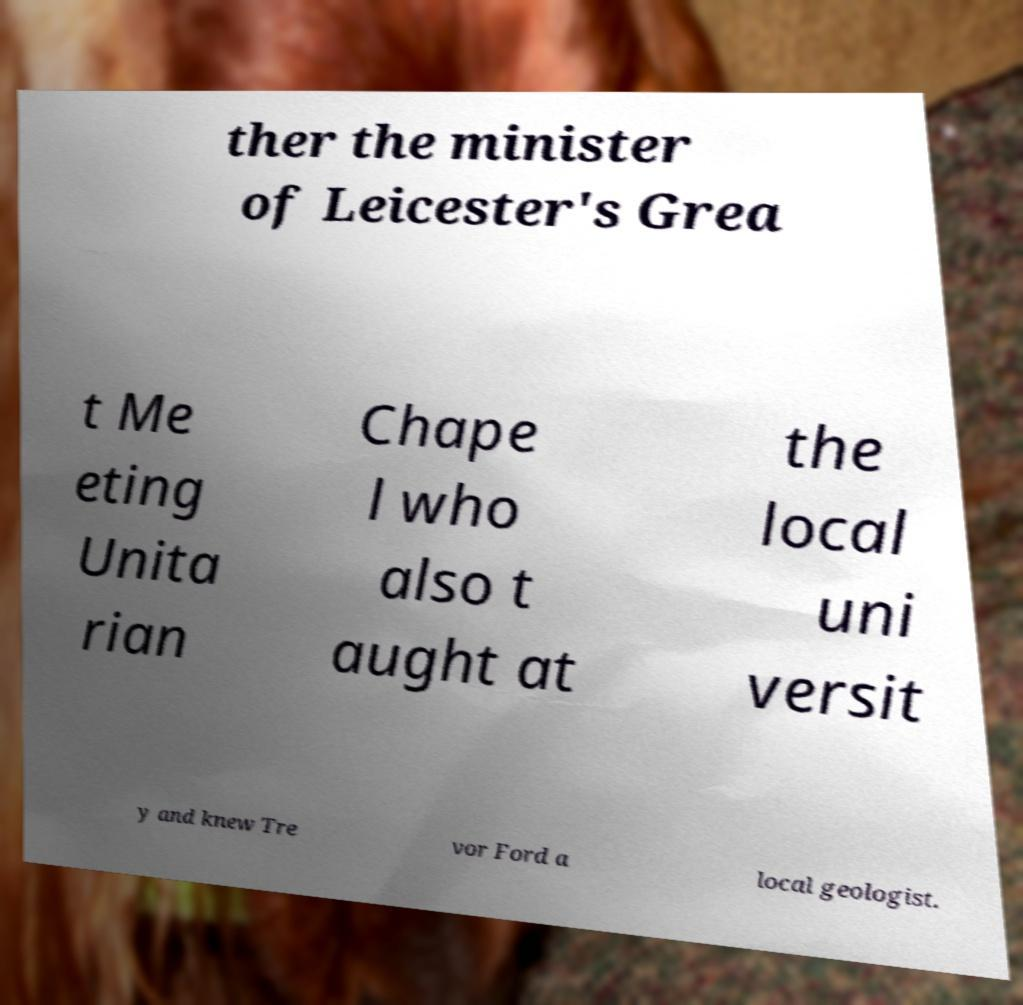Could you extract and type out the text from this image? ther the minister of Leicester's Grea t Me eting Unita rian Chape l who also t aught at the local uni versit y and knew Tre vor Ford a local geologist. 